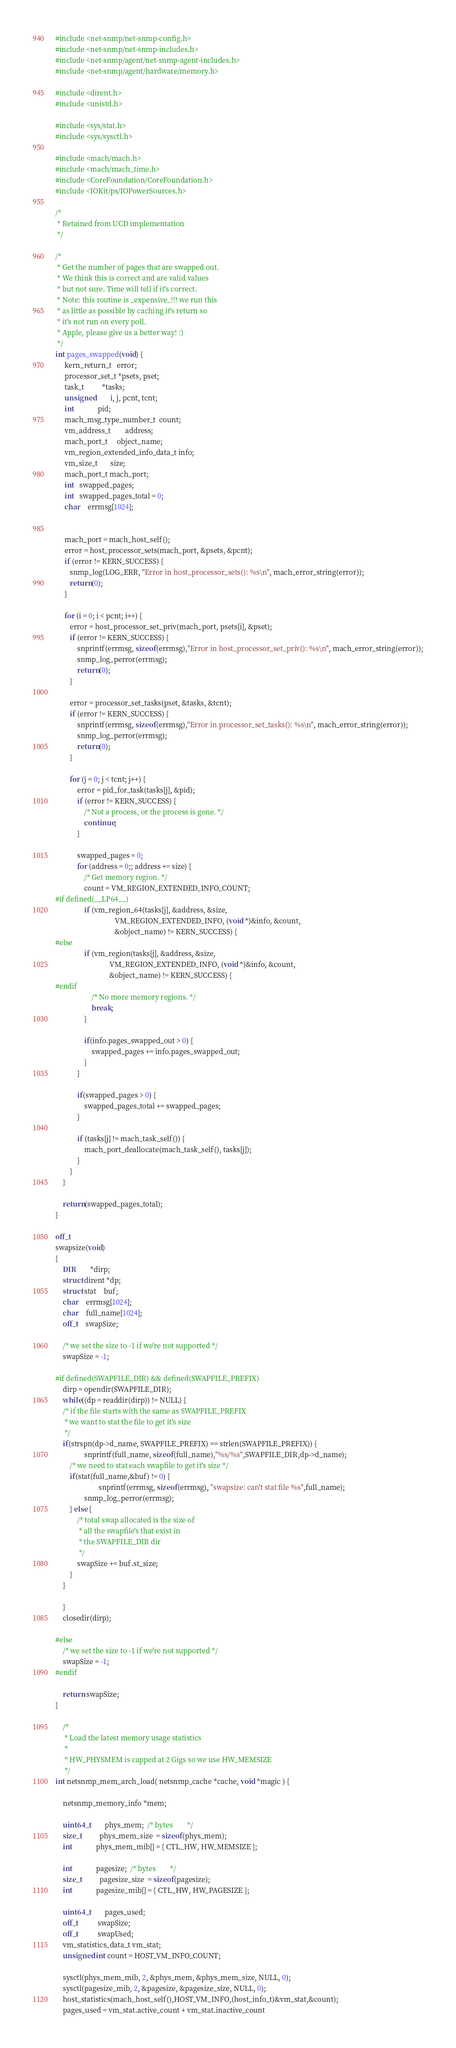<code> <loc_0><loc_0><loc_500><loc_500><_C_>#include <net-snmp/net-snmp-config.h>
#include <net-snmp/net-snmp-includes.h>
#include <net-snmp/agent/net-snmp-agent-includes.h>
#include <net-snmp/agent/hardware/memory.h>

#include <dirent.h>
#include <unistd.h>

#include <sys/stat.h>
#include <sys/sysctl.h>

#include <mach/mach.h>
#include <mach/mach_time.h>
#include <CoreFoundation/CoreFoundation.h>
#include <IOKit/ps/IOPowerSources.h>

/*
 * Retained from UCD implementation
 */

/*
 * Get the number of pages that are swapped out.
 * We think this is correct and are valid values
 * but not sure. Time will tell if it's correct.
 * Note: this routine is _expensive_!!! we run this
 * as little as possible by caching it's return so
 * it's not run on every poll.
 * Apple, please give us a better way! :)
 */
int pages_swapped(void) {
     kern_return_t   error;
     processor_set_t *psets, pset;
     task_t          *tasks;
     unsigned        i, j, pcnt, tcnt;
     int             pid;
     mach_msg_type_number_t  count;
     vm_address_t        address;
     mach_port_t     object_name;
     vm_region_extended_info_data_t info;
     vm_size_t       size;
     mach_port_t mach_port;
     int   swapped_pages;
     int   swapped_pages_total = 0;
     char    errmsg[1024];


     mach_port = mach_host_self();
     error = host_processor_sets(mach_port, &psets, &pcnt);
     if (error != KERN_SUCCESS) {
        snmp_log(LOG_ERR, "Error in host_processor_sets(): %s\n", mach_error_string(error));
        return(0);
     }

     for (i = 0; i < pcnt; i++) {
        error = host_processor_set_priv(mach_port, psets[i], &pset);
        if (error != KERN_SUCCESS) {
            snprintf(errmsg, sizeof(errmsg),"Error in host_processor_set_priv(): %s\n", mach_error_string(error));
            snmp_log_perror(errmsg);
            return(0);
        }

        error = processor_set_tasks(pset, &tasks, &tcnt);
        if (error != KERN_SUCCESS) {
            snprintf(errmsg, sizeof(errmsg),"Error in processor_set_tasks(): %s\n", mach_error_string(error));
            snmp_log_perror(errmsg);
            return(0);
        }

        for (j = 0; j < tcnt; j++) {
            error = pid_for_task(tasks[j], &pid);
            if (error != KERN_SUCCESS) {
                /* Not a process, or the process is gone. */
                continue;
            }

            swapped_pages = 0;
            for (address = 0;; address += size) {
                /* Get memory region. */
                count = VM_REGION_EXTENDED_INFO_COUNT; 
#if defined(__LP64__)
                if (vm_region_64(tasks[j], &address, &size,
                                 VM_REGION_EXTENDED_INFO, (void *)&info, &count,
                                 &object_name) != KERN_SUCCESS) {
#else
                if (vm_region(tasks[j], &address, &size,
                              VM_REGION_EXTENDED_INFO, (void *)&info, &count,
                              &object_name) != KERN_SUCCESS) {
#endif
                    /* No more memory regions. */
                    break;
                }
            
                if(info.pages_swapped_out > 0) {
                    swapped_pages += info.pages_swapped_out;
                } 
            }
           
            if(swapped_pages > 0) {
                swapped_pages_total += swapped_pages; 
            }

            if (tasks[j] != mach_task_self()) {
                mach_port_deallocate(mach_task_self(), tasks[j]);
            }  
        }
    }

    return(swapped_pages_total);
}

off_t 
swapsize(void)
{
    DIR		*dirp;
    struct dirent *dp;
    struct stat	buf;
    char	errmsg[1024];
    char	full_name[1024];
    off_t	swapSize;

    /* we set the size to -1 if we're not supported */
    swapSize = -1;

#if defined(SWAPFILE_DIR) && defined(SWAPFILE_PREFIX)
    dirp = opendir(SWAPFILE_DIR);
    while((dp = readdir(dirp)) != NULL) {
	/* if the file starts with the same as SWAPFILE_PREFIX
	 * we want to stat the file to get it's size
	 */
	if(strspn(dp->d_name, SWAPFILE_PREFIX) == strlen(SWAPFILE_PREFIX)) {
                snprintf(full_name, sizeof(full_name),"%s/%s",SWAPFILE_DIR,dp->d_name);
		/* we need to stat each swapfile to get it's size */
		if(stat(full_name,&buf) != 0) {
                        snprintf(errmsg, sizeof(errmsg), "swapsize: can't stat file %s",full_name);
	    		snmp_log_perror(errmsg);
		} else {
			/* total swap allocated is the size of
			 * all the swapfile's that exist in
			 * the SWAPFILE_DIR dir
			 */ 
			swapSize += buf.st_size;  
		}
	}

    }
    closedir(dirp);
    
#else
    /* we set the size to -1 if we're not supported */
    swapSize = -1;
#endif

    return swapSize;
}

    /*
     * Load the latest memory usage statistics
     *
     * HW_PHYSMEM is capped at 2 Gigs so we use HW_MEMSIZE
     */
int netsnmp_mem_arch_load( netsnmp_cache *cache, void *magic ) {

    netsnmp_memory_info *mem;

    uint64_t        phys_mem;  /* bytes        */
    size_t          phys_mem_size  = sizeof(phys_mem);
    int             phys_mem_mib[] = { CTL_HW, HW_MEMSIZE };

    int             pagesize;  /* bytes        */
    size_t          pagesize_size  = sizeof(pagesize);
    int             pagesize_mib[] = { CTL_HW, HW_PAGESIZE };

    uint64_t        pages_used;
    off_t           swapSize;
    off_t           swapUsed;
    vm_statistics_data_t vm_stat;
    unsigned int count = HOST_VM_INFO_COUNT;

    sysctl(phys_mem_mib, 2, &phys_mem, &phys_mem_size, NULL, 0);
    sysctl(pagesize_mib, 2, &pagesize, &pagesize_size, NULL, 0);
    host_statistics(mach_host_self(),HOST_VM_INFO,(host_info_t)&vm_stat,&count);
    pages_used = vm_stat.active_count + vm_stat.inactive_count</code> 